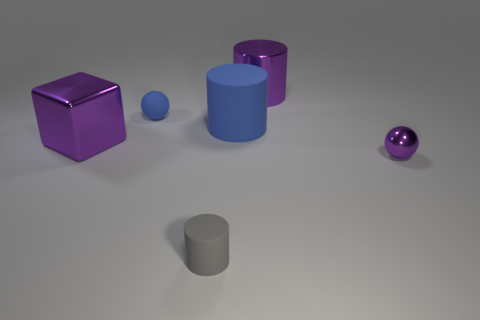What shapes can be identified in this image? In this image, there are several shapes including a purple cube, a smaller blue cylinder, a large purple cylinder, a tiny purple sphere, a grey cylinder, and a larger, shinier purple sphere. 